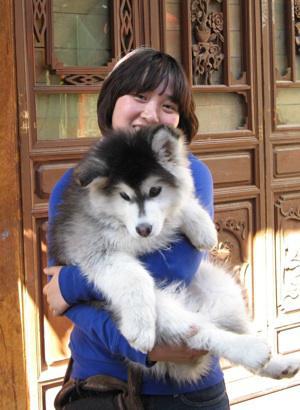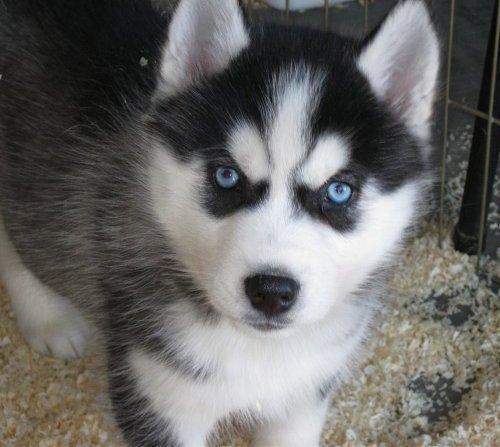The first image is the image on the left, the second image is the image on the right. Assess this claim about the two images: "The left and right image contains the same number of dogs.". Correct or not? Answer yes or no. Yes. The first image is the image on the left, the second image is the image on the right. Examine the images to the left and right. Is the description "There are exactly three dogs in total." accurate? Answer yes or no. No. 